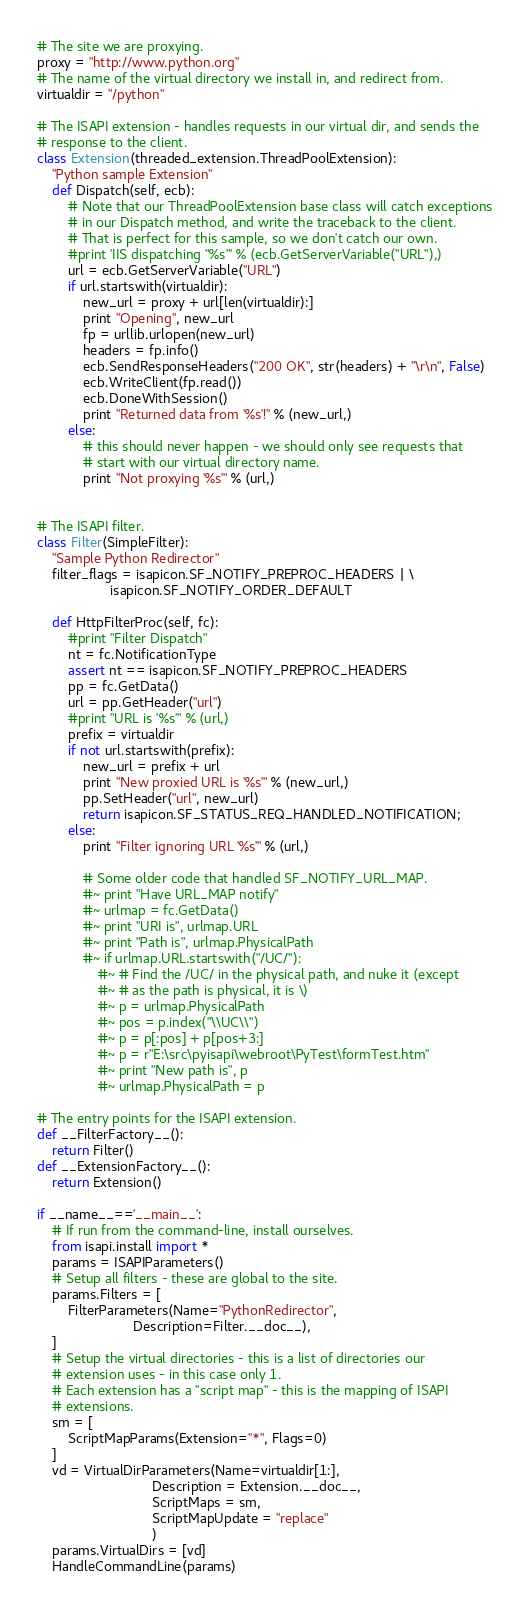Convert code to text. <code><loc_0><loc_0><loc_500><loc_500><_Python_>
# The site we are proxying.
proxy = "http://www.python.org"
# The name of the virtual directory we install in, and redirect from.
virtualdir = "/python"

# The ISAPI extension - handles requests in our virtual dir, and sends the
# response to the client.
class Extension(threaded_extension.ThreadPoolExtension):
    "Python sample Extension"
    def Dispatch(self, ecb):
        # Note that our ThreadPoolExtension base class will catch exceptions
        # in our Dispatch method, and write the traceback to the client.
        # That is perfect for this sample, so we don't catch our own.
        #print 'IIS dispatching "%s"' % (ecb.GetServerVariable("URL"),)
        url = ecb.GetServerVariable("URL")
        if url.startswith(virtualdir):
            new_url = proxy + url[len(virtualdir):]
            print "Opening", new_url
            fp = urllib.urlopen(new_url)
            headers = fp.info()
            ecb.SendResponseHeaders("200 OK", str(headers) + "\r\n", False)
            ecb.WriteClient(fp.read())
            ecb.DoneWithSession()
            print "Returned data from '%s'!" % (new_url,)
        else:
            # this should never happen - we should only see requests that
            # start with our virtual directory name.
            print "Not proxying '%s'" % (url,)


# The ISAPI filter.
class Filter(SimpleFilter):
    "Sample Python Redirector"
    filter_flags = isapicon.SF_NOTIFY_PREPROC_HEADERS | \
                   isapicon.SF_NOTIFY_ORDER_DEFAULT

    def HttpFilterProc(self, fc):
        #print "Filter Dispatch"
        nt = fc.NotificationType
        assert nt == isapicon.SF_NOTIFY_PREPROC_HEADERS
        pp = fc.GetData()
        url = pp.GetHeader("url")
        #print "URL is '%s'" % (url,)
        prefix = virtualdir
        if not url.startswith(prefix):
            new_url = prefix + url
            print "New proxied URL is '%s'" % (new_url,)
            pp.SetHeader("url", new_url)
            return isapicon.SF_STATUS_REQ_HANDLED_NOTIFICATION;
        else:
            print "Filter ignoring URL '%s'" % (url,)
            
            # Some older code that handled SF_NOTIFY_URL_MAP.
            #~ print "Have URL_MAP notify"
            #~ urlmap = fc.GetData()
            #~ print "URI is", urlmap.URL
            #~ print "Path is", urlmap.PhysicalPath
            #~ if urlmap.URL.startswith("/UC/"):
                #~ # Find the /UC/ in the physical path, and nuke it (except 
                #~ # as the path is physical, it is \)
                #~ p = urlmap.PhysicalPath
                #~ pos = p.index("\\UC\\")
                #~ p = p[:pos] + p[pos+3:]
                #~ p = r"E:\src\pyisapi\webroot\PyTest\formTest.htm"
                #~ print "New path is", p
                #~ urlmap.PhysicalPath = p

# The entry points for the ISAPI extension.
def __FilterFactory__():
    return Filter()
def __ExtensionFactory__():
    return Extension()

if __name__=='__main__':
    # If run from the command-line, install ourselves.
    from isapi.install import *
    params = ISAPIParameters()
    # Setup all filters - these are global to the site.
    params.Filters = [
        FilterParameters(Name="PythonRedirector",
                         Description=Filter.__doc__),
    ]
    # Setup the virtual directories - this is a list of directories our
    # extension uses - in this case only 1.
    # Each extension has a "script map" - this is the mapping of ISAPI
    # extensions.
    sm = [
        ScriptMapParams(Extension="*", Flags=0)
    ]
    vd = VirtualDirParameters(Name=virtualdir[1:],
                              Description = Extension.__doc__,
                              ScriptMaps = sm,
                              ScriptMapUpdate = "replace"
                              )
    params.VirtualDirs = [vd]
    HandleCommandLine(params)
</code> 